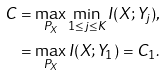<formula> <loc_0><loc_0><loc_500><loc_500>C & = \max _ { P _ { X } } \min _ { 1 \leq j \leq K } I ( X ; Y _ { j } ) , \\ & = \max _ { P _ { X } } I ( X ; Y _ { 1 } ) = C _ { 1 } .</formula> 